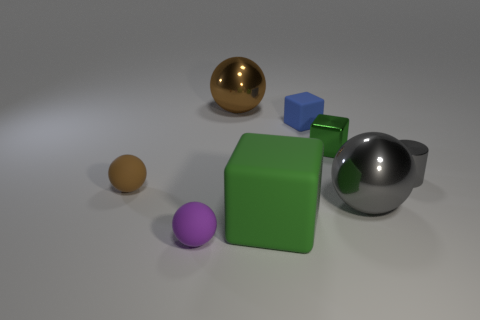What number of objects are either cubes that are left of the green shiny block or rubber spheres that are left of the tiny purple sphere? In the image, there is one blue cube to the left of the green shiny block and one orange sphere to the left of the tiny purple sphere. Additionally, there is a golden sphere that is not to the left of either the green block or the purple sphere and therefore does not meet the criteria. Considering the positional requirement detailed in the question, the total count of objects that fulfill the criteria is 2. 